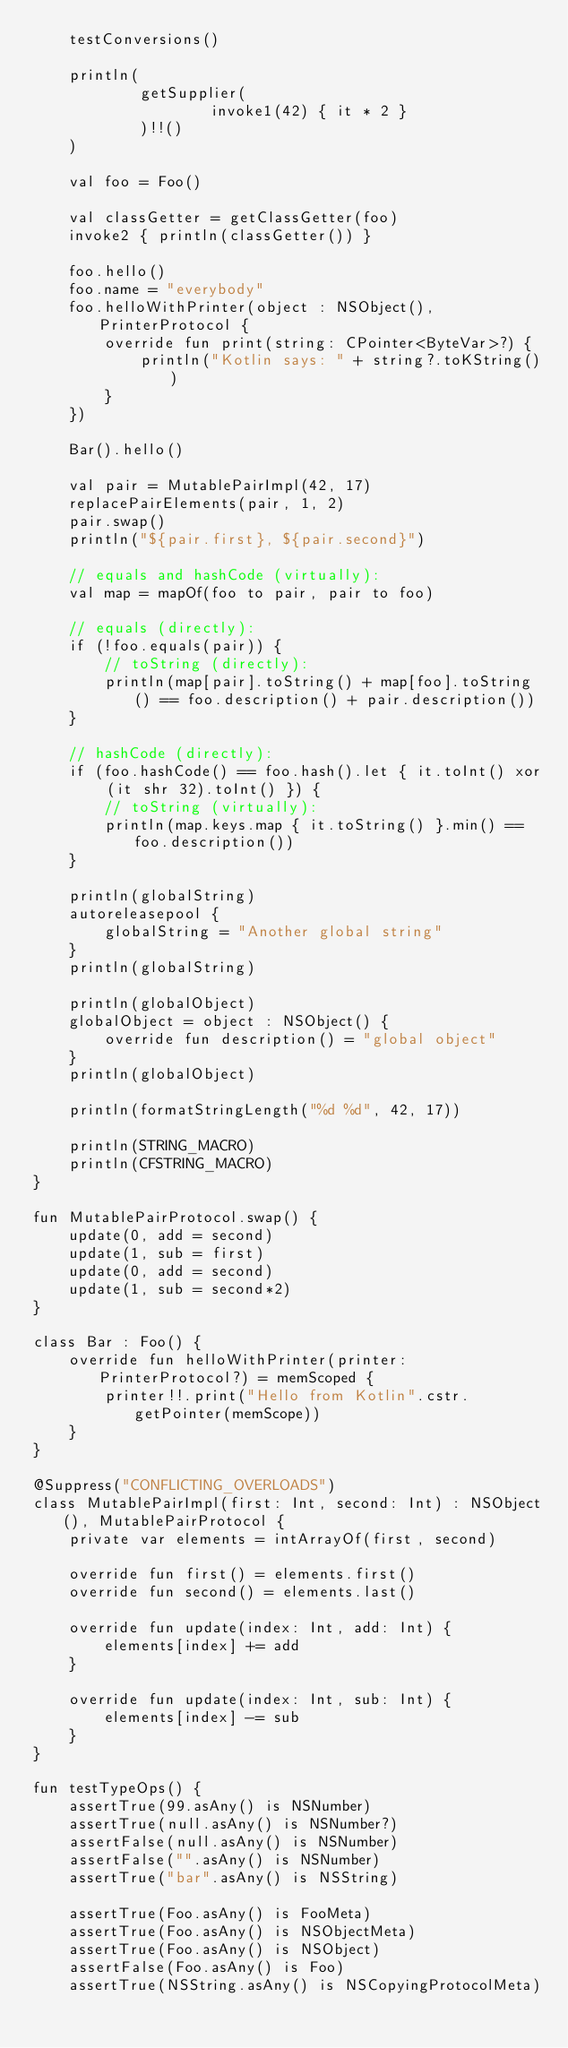Convert code to text. <code><loc_0><loc_0><loc_500><loc_500><_Kotlin_>    testConversions()

    println(
            getSupplier(
                    invoke1(42) { it * 2 }
            )!!()
    )

    val foo = Foo()

    val classGetter = getClassGetter(foo)
    invoke2 { println(classGetter()) }

    foo.hello()
    foo.name = "everybody"
    foo.helloWithPrinter(object : NSObject(), PrinterProtocol {
        override fun print(string: CPointer<ByteVar>?) {
            println("Kotlin says: " + string?.toKString())
        }
    })

    Bar().hello()

    val pair = MutablePairImpl(42, 17)
    replacePairElements(pair, 1, 2)
    pair.swap()
    println("${pair.first}, ${pair.second}")

    // equals and hashCode (virtually):
    val map = mapOf(foo to pair, pair to foo)

    // equals (directly):
    if (!foo.equals(pair)) {
        // toString (directly):
        println(map[pair].toString() + map[foo].toString() == foo.description() + pair.description())
    }

    // hashCode (directly):
    if (foo.hashCode() == foo.hash().let { it.toInt() xor (it shr 32).toInt() }) {
        // toString (virtually):
        println(map.keys.map { it.toString() }.min() == foo.description())
    }

    println(globalString)
    autoreleasepool {
        globalString = "Another global string"
    }
    println(globalString)

    println(globalObject)
    globalObject = object : NSObject() {
        override fun description() = "global object"
    }
    println(globalObject)

    println(formatStringLength("%d %d", 42, 17))

    println(STRING_MACRO)
    println(CFSTRING_MACRO)
}

fun MutablePairProtocol.swap() {
    update(0, add = second)
    update(1, sub = first)
    update(0, add = second)
    update(1, sub = second*2)
}

class Bar : Foo() {
    override fun helloWithPrinter(printer: PrinterProtocol?) = memScoped {
        printer!!.print("Hello from Kotlin".cstr.getPointer(memScope))
    }
}

@Suppress("CONFLICTING_OVERLOADS")
class MutablePairImpl(first: Int, second: Int) : NSObject(), MutablePairProtocol {
    private var elements = intArrayOf(first, second)

    override fun first() = elements.first()
    override fun second() = elements.last()

    override fun update(index: Int, add: Int) {
        elements[index] += add
    }

    override fun update(index: Int, sub: Int) {
        elements[index] -= sub
    }
}

fun testTypeOps() {
    assertTrue(99.asAny() is NSNumber)
    assertTrue(null.asAny() is NSNumber?)
    assertFalse(null.asAny() is NSNumber)
    assertFalse("".asAny() is NSNumber)
    assertTrue("bar".asAny() is NSString)

    assertTrue(Foo.asAny() is FooMeta)
    assertTrue(Foo.asAny() is NSObjectMeta)
    assertTrue(Foo.asAny() is NSObject)
    assertFalse(Foo.asAny() is Foo)
    assertTrue(NSString.asAny() is NSCopyingProtocolMeta)</code> 